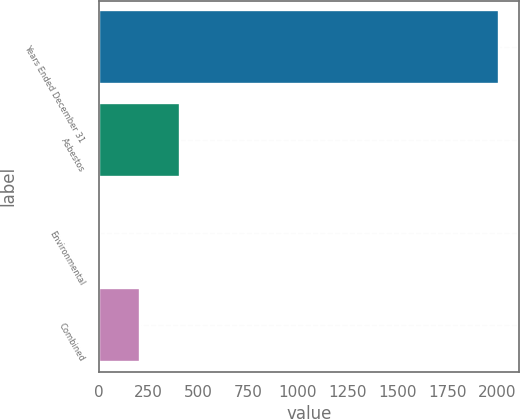<chart> <loc_0><loc_0><loc_500><loc_500><bar_chart><fcel>Years Ended December 31<fcel>Asbestos<fcel>Environmental<fcel>Combined<nl><fcel>2011<fcel>404.6<fcel>3<fcel>203.8<nl></chart> 